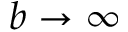Convert formula to latex. <formula><loc_0><loc_0><loc_500><loc_500>b \rightarrow \infty</formula> 